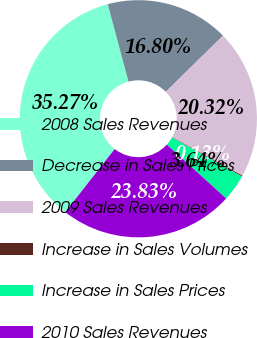Convert chart to OTSL. <chart><loc_0><loc_0><loc_500><loc_500><pie_chart><fcel>2008 Sales Revenues<fcel>Decrease in Sales Prices<fcel>2009 Sales Revenues<fcel>Increase in Sales Volumes<fcel>Increase in Sales Prices<fcel>2010 Sales Revenues<nl><fcel>35.27%<fcel>16.8%<fcel>20.32%<fcel>0.13%<fcel>3.64%<fcel>23.83%<nl></chart> 